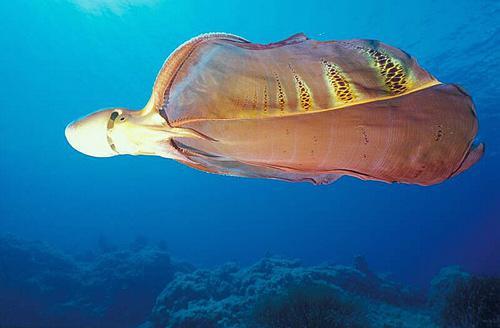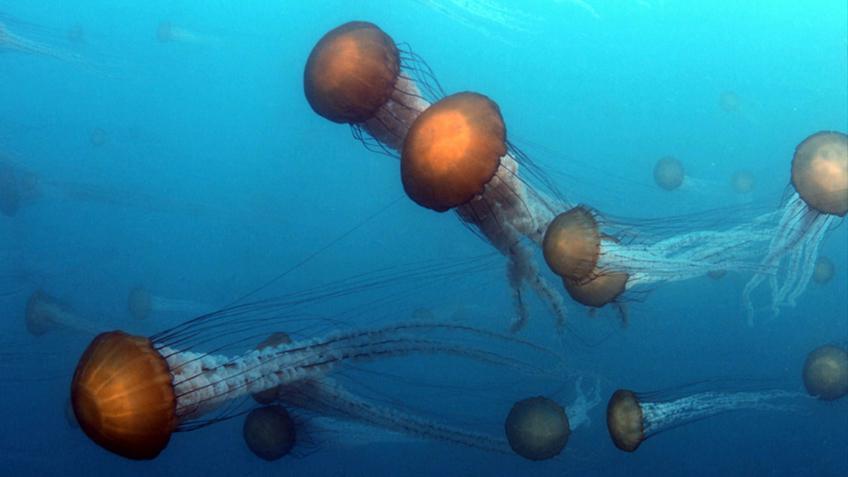The first image is the image on the left, the second image is the image on the right. For the images shown, is this caption "Left image shows a prominent jellyfish in foreground with many smaller jellyfish in the background." true? Answer yes or no. No. The first image is the image on the left, the second image is the image on the right. For the images displayed, is the sentence "There is a single jellyfish in the image on the left" factually correct? Answer yes or no. Yes. 